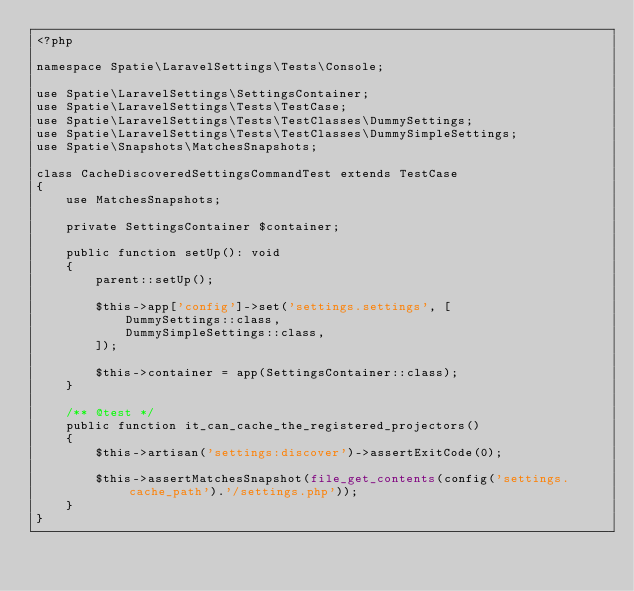Convert code to text. <code><loc_0><loc_0><loc_500><loc_500><_PHP_><?php

namespace Spatie\LaravelSettings\Tests\Console;

use Spatie\LaravelSettings\SettingsContainer;
use Spatie\LaravelSettings\Tests\TestCase;
use Spatie\LaravelSettings\Tests\TestClasses\DummySettings;
use Spatie\LaravelSettings\Tests\TestClasses\DummySimpleSettings;
use Spatie\Snapshots\MatchesSnapshots;

class CacheDiscoveredSettingsCommandTest extends TestCase
{
    use MatchesSnapshots;

    private SettingsContainer $container;

    public function setUp(): void
    {
        parent::setUp();

        $this->app['config']->set('settings.settings', [
            DummySettings::class,
            DummySimpleSettings::class,
        ]);

        $this->container = app(SettingsContainer::class);
    }

    /** @test */
    public function it_can_cache_the_registered_projectors()
    {
        $this->artisan('settings:discover')->assertExitCode(0);

        $this->assertMatchesSnapshot(file_get_contents(config('settings.cache_path').'/settings.php'));
    }
}
</code> 